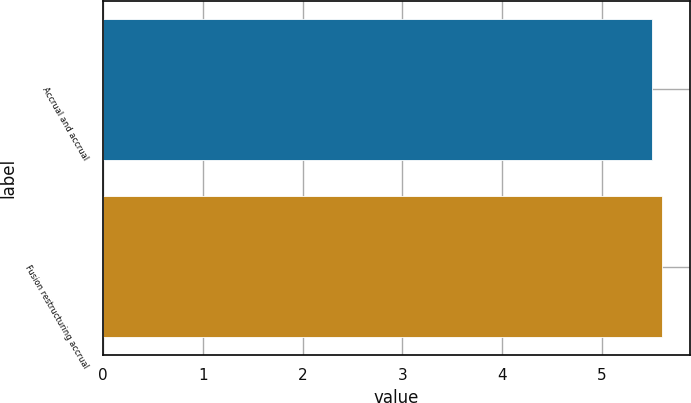<chart> <loc_0><loc_0><loc_500><loc_500><bar_chart><fcel>Accrual and accrual<fcel>Fusion restructuring accrual<nl><fcel>5.5<fcel>5.6<nl></chart> 